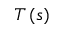<formula> <loc_0><loc_0><loc_500><loc_500>T \left ( s \right )</formula> 